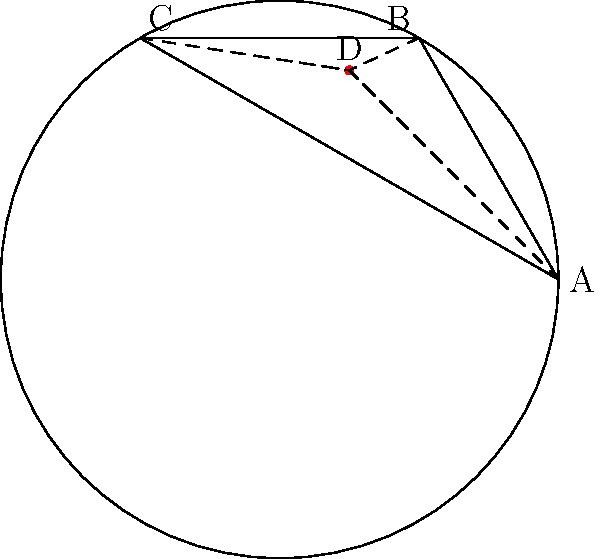In designing a dome-shaped venue with non-Euclidean lighting, you're considering a hyperbolic model where light travels along geodesics. If points A, B, and C represent light sources on the dome's edge, and D is a central point, how would the sum of angles in triangle ABD compare to a Euclidean triangle, and how might this affect your lighting design? To understand how non-Euclidean geometry affects the lighting design in a dome-shaped venue, let's consider the properties of hyperbolic geometry:

1. In Euclidean geometry, the sum of angles in a triangle is always 180°. However, in hyperbolic geometry, this sum is always less than 180°.

2. The difference between 180° and the actual sum of angles in a hyperbolic triangle is called the defect. The larger the triangle, the greater the defect.

3. In the hyperbolic model, straight lines appear curved when represented in Euclidean space. These curves are called geodesics and represent the shortest path between two points in hyperbolic space.

4. Light in this model would travel along these geodesics, creating unique lighting effects compared to Euclidean space.

5. In the diagram, triangle ABD would have a sum of angles less than 180°. This means that light from sources A and B would converge at D at a smaller angle than expected in Euclidean space.

6. The practical implication for lighting design:
   a) Light beams would appear to curve, creating interesting patterns on the dome's surface.
   b) The convergence of light at central points like D would be more intense than in Euclidean space.
   c) The apparent distance between light sources might seem greater, potentially creating a more spacious feel.

7. To utilize this in design:
   a) Place light sources strategically along the dome's edge to create unexpected convergence points.
   b) Use the curved path of light to create unique patterns and atmospheres.
   c) Leverage the increased intensity at convergence points for dramatic lighting effects.

By understanding and applying these principles, you can create a lighting design that takes full advantage of the non-Euclidean properties of your dome-shaped venue, resulting in a truly unique and immersive atmosphere.
Answer: Sum of angles < 180°; curved light paths, intense convergence points 